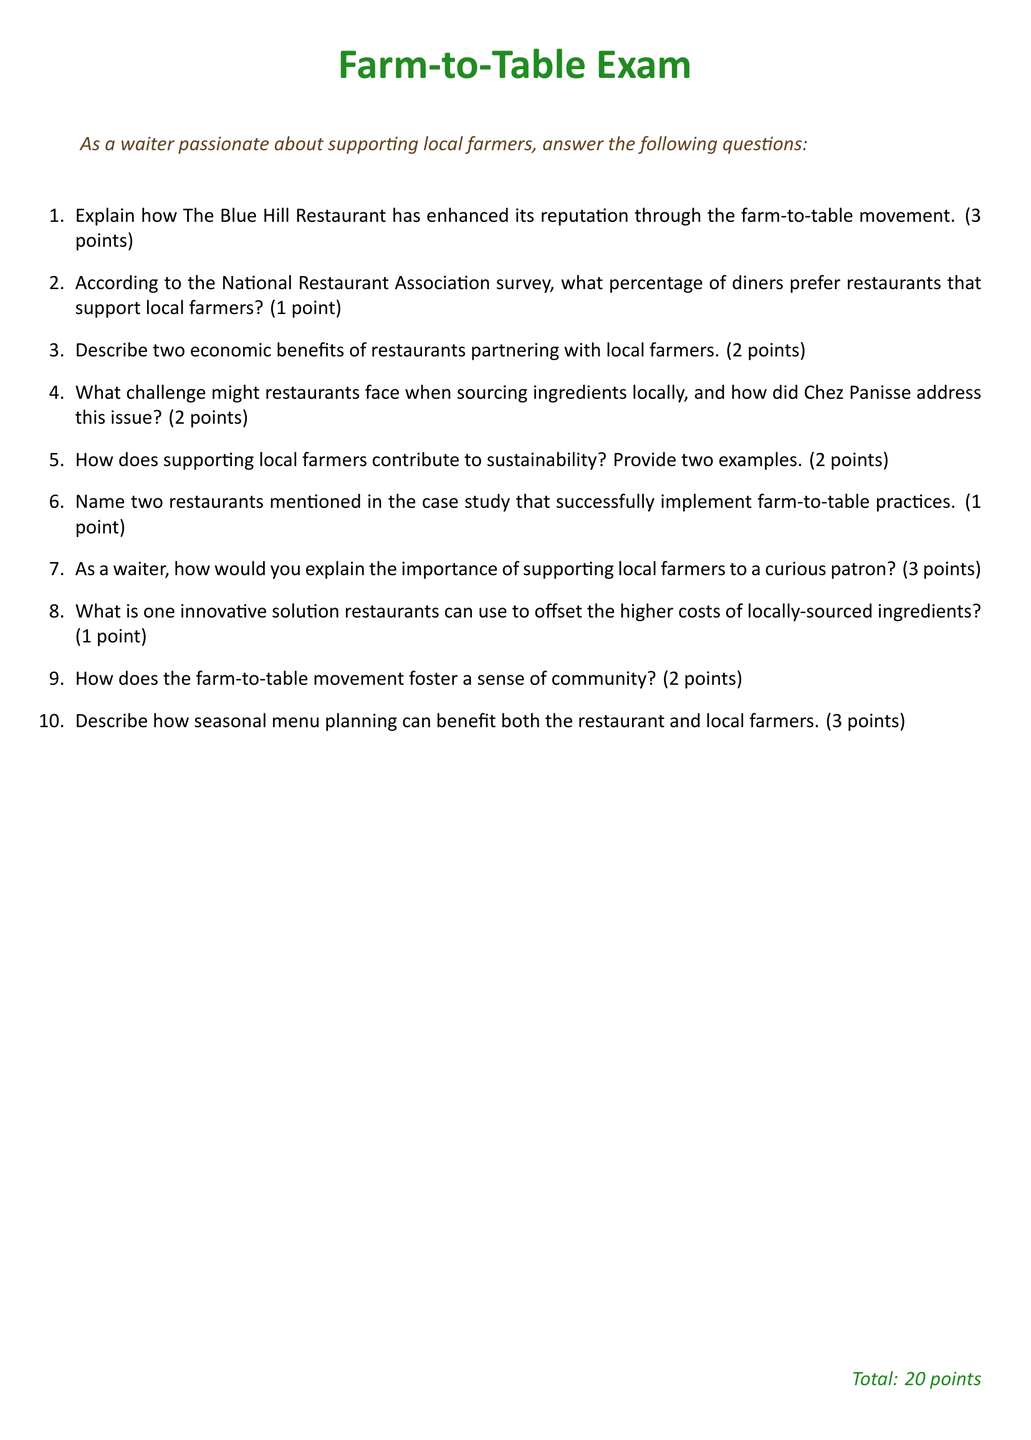What percentage of diners prefer restaurants that support local farmers? The document explicitly mentions the percentage of diners who prefer local farm-supporting restaurants according to a survey.
Answer: 1 point Name two restaurants mentioned in the case study that successfully implement farm-to-table practices. The question asks for specific examples of restaurants noted in the case study for farm-to-table practices, which are mentioned directly in the text.
Answer: Two restaurants How many points is the explanation of The Blue Hill Restaurant's strategy worth? The points assigned to answering the question about The Blue Hill Restaurant’s reputation are listed in the document.
Answer: 3 points What is one innovative solution restaurants can use to offset the higher costs of locally-sourced ingredients? The exam contains a specific question about innovative solutions to cost issues related to local sourcing.
Answer: 1 point Describe two economic benefits of restaurants partnering with local farmers. This question prompts for specific benefits noted in the case study, highlighting economic aspects.
Answer: 2 points How does the farm-to-table movement foster a sense of community? The document asks for reasoning related to community building through the farm-to-table movement, which is referenced in the questions.
Answer: 2 points What challenge might restaurants face when sourcing ingredients locally? This question seeks a specific challenge noted in the case study about local sourcing, which is addressed directly in the text.
Answer: 2 points Explain how seasonal menu planning benefits both the restaurant and local farmers. The question focuses on specific mutual benefits detailed in the case study regarding seasonal menu planning.
Answer: 3 points How many total points is the exam worth? The document states the total points available for the exam at the end, which rounds up the entire test's value.
Answer: 20 points 